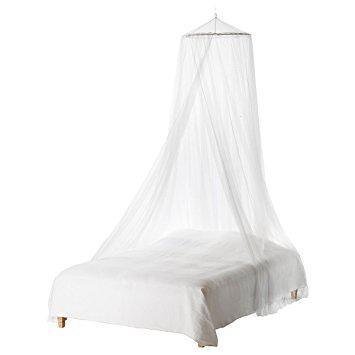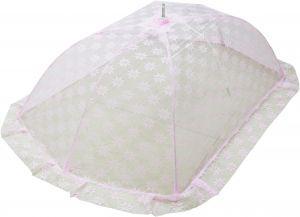The first image is the image on the left, the second image is the image on the right. Analyze the images presented: Is the assertion "The right image shows at least one bed canopy, but no bed is shown." valid? Answer yes or no. Yes. The first image is the image on the left, the second image is the image on the right. Considering the images on both sides, is "There are two bed with two white canopies." valid? Answer yes or no. No. 